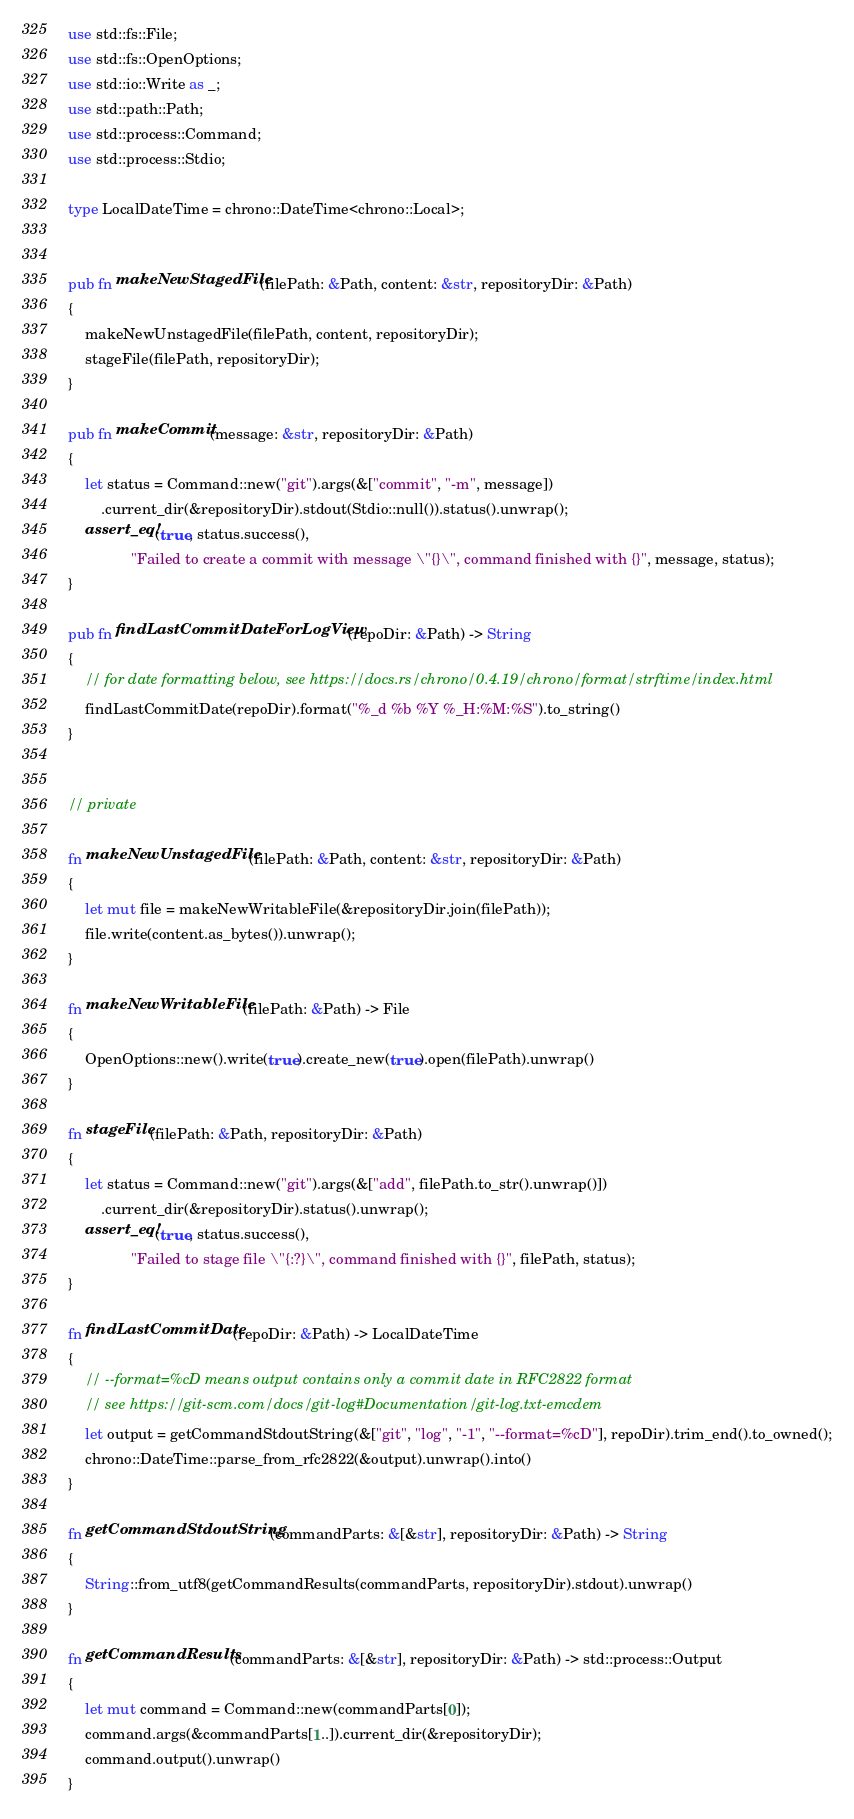<code> <loc_0><loc_0><loc_500><loc_500><_Rust_>use std::fs::File;
use std::fs::OpenOptions;
use std::io::Write as _;
use std::path::Path;
use std::process::Command;
use std::process::Stdio;

type LocalDateTime = chrono::DateTime<chrono::Local>;


pub fn makeNewStagedFile(filePath: &Path, content: &str, repositoryDir: &Path)
{
    makeNewUnstagedFile(filePath, content, repositoryDir);
    stageFile(filePath, repositoryDir);
}

pub fn makeCommit(message: &str, repositoryDir: &Path)
{
    let status = Command::new("git").args(&["commit", "-m", message])
        .current_dir(&repositoryDir).stdout(Stdio::null()).status().unwrap();
    assert_eq!(true, status.success(),
               "Failed to create a commit with message \"{}\", command finished with {}", message, status);
}

pub fn findLastCommitDateForLogView(repoDir: &Path) -> String
{
    // for date formatting below, see https://docs.rs/chrono/0.4.19/chrono/format/strftime/index.html
    findLastCommitDate(repoDir).format("%_d %b %Y %_H:%M:%S").to_string()
}


// private

fn makeNewUnstagedFile(filePath: &Path, content: &str, repositoryDir: &Path)
{
    let mut file = makeNewWritableFile(&repositoryDir.join(filePath));
    file.write(content.as_bytes()).unwrap();
}

fn makeNewWritableFile(filePath: &Path) -> File
{
    OpenOptions::new().write(true).create_new(true).open(filePath).unwrap()
}

fn stageFile(filePath: &Path, repositoryDir: &Path)
{
    let status = Command::new("git").args(&["add", filePath.to_str().unwrap()])
        .current_dir(&repositoryDir).status().unwrap();
    assert_eq!(true, status.success(),
               "Failed to stage file \"{:?}\", command finished with {}", filePath, status);
}

fn findLastCommitDate(repoDir: &Path) -> LocalDateTime
{
    // --format=%cD means output contains only a commit date in RFC2822 format
    // see https://git-scm.com/docs/git-log#Documentation/git-log.txt-emcdem
    let output = getCommandStdoutString(&["git", "log", "-1", "--format=%cD"], repoDir).trim_end().to_owned();
    chrono::DateTime::parse_from_rfc2822(&output).unwrap().into()
}

fn getCommandStdoutString(commandParts: &[&str], repositoryDir: &Path) -> String
{
    String::from_utf8(getCommandResults(commandParts, repositoryDir).stdout).unwrap()
}

fn getCommandResults(commandParts: &[&str], repositoryDir: &Path) -> std::process::Output
{
    let mut command = Command::new(commandParts[0]);
    command.args(&commandParts[1..]).current_dir(&repositoryDir);
    command.output().unwrap()
}
</code> 